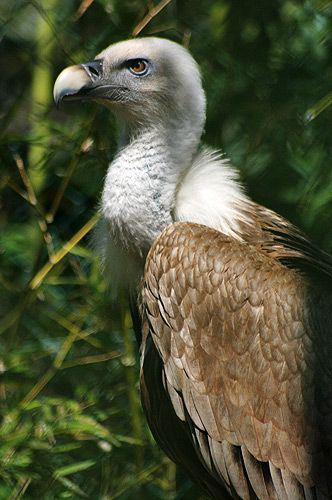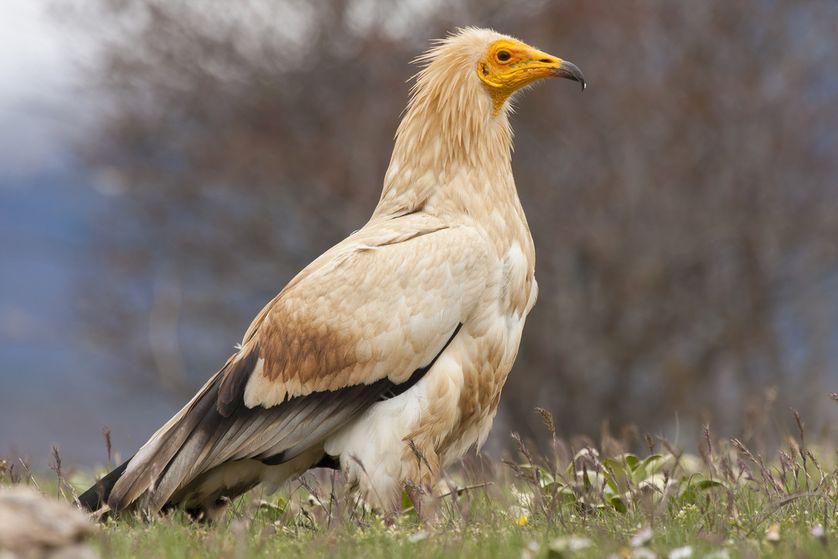The first image is the image on the left, the second image is the image on the right. Given the left and right images, does the statement "There is no more than one bird on the left image." hold true? Answer yes or no. Yes. 